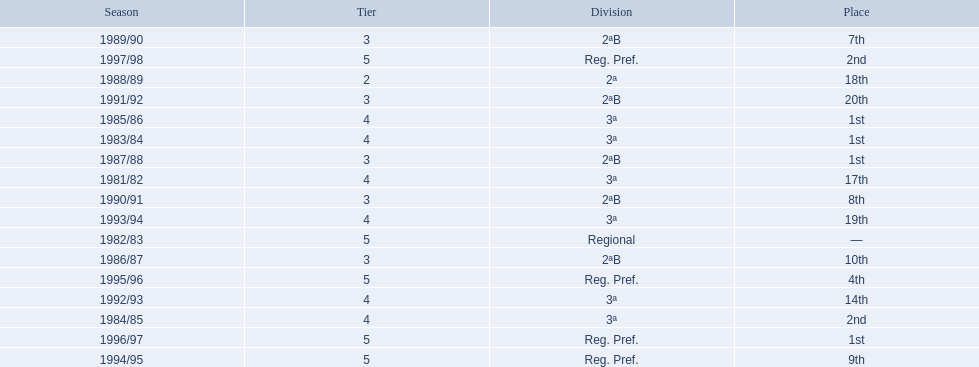Which years did the team have a season? 1981/82, 1982/83, 1983/84, 1984/85, 1985/86, 1986/87, 1987/88, 1988/89, 1989/90, 1990/91, 1991/92, 1992/93, 1993/94, 1994/95, 1995/96, 1996/97, 1997/98. Which of those years did the team place outside the top 10? 1981/82, 1988/89, 1991/92, 1992/93, 1993/94. Which of the years in which the team placed outside the top 10 did they have their worst performance? 1991/92. 